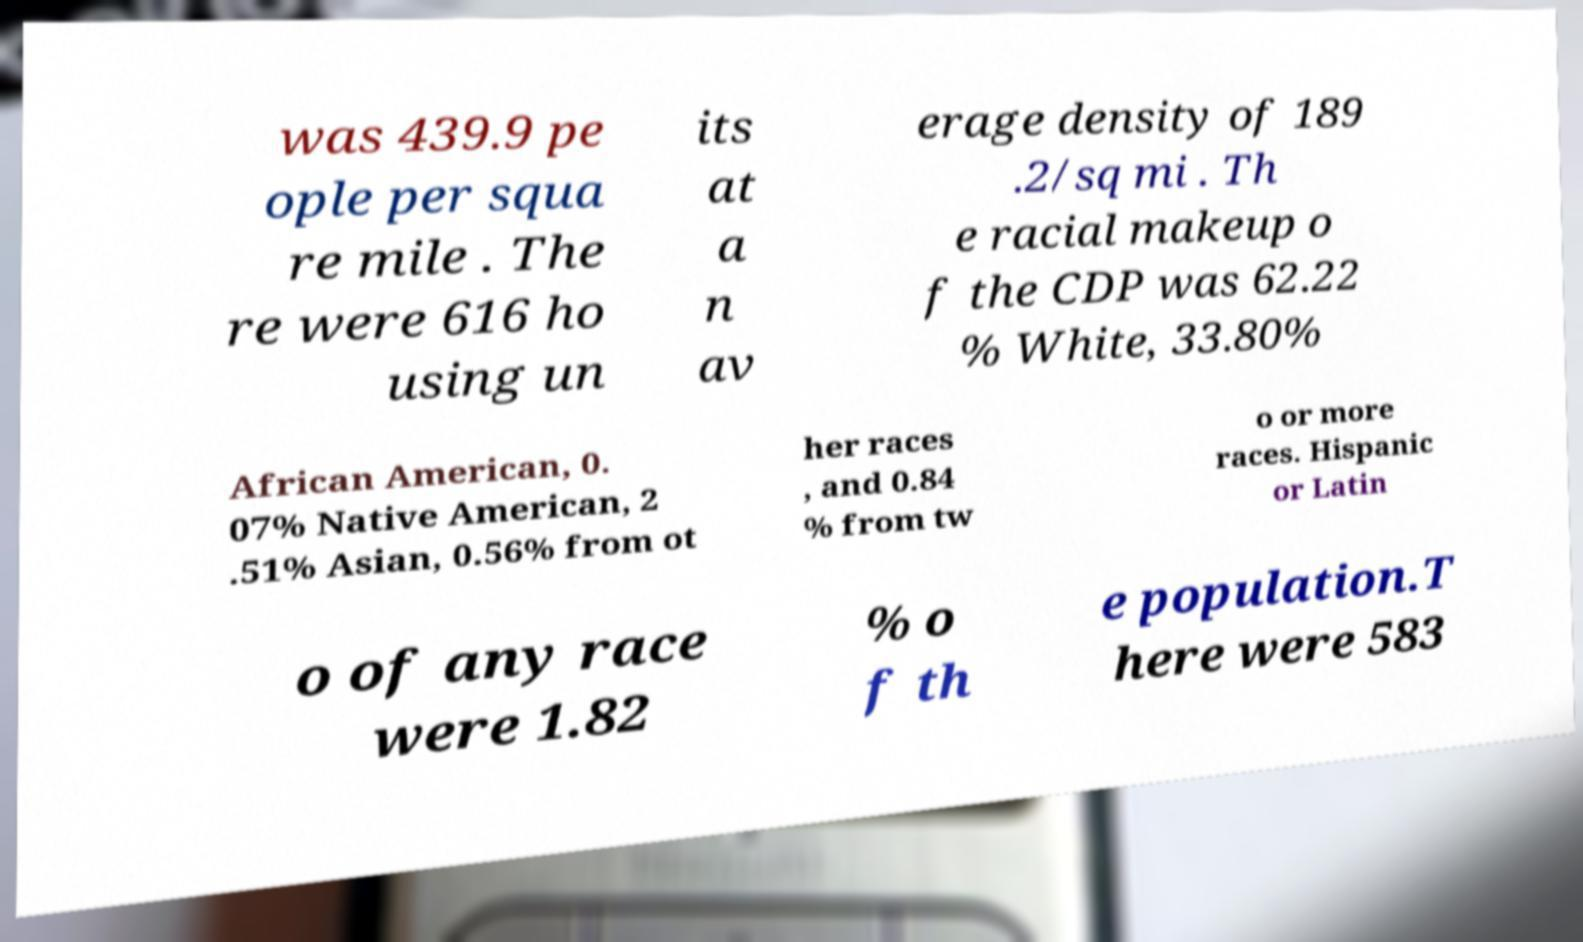For documentation purposes, I need the text within this image transcribed. Could you provide that? was 439.9 pe ople per squa re mile . The re were 616 ho using un its at a n av erage density of 189 .2/sq mi . Th e racial makeup o f the CDP was 62.22 % White, 33.80% African American, 0. 07% Native American, 2 .51% Asian, 0.56% from ot her races , and 0.84 % from tw o or more races. Hispanic or Latin o of any race were 1.82 % o f th e population.T here were 583 